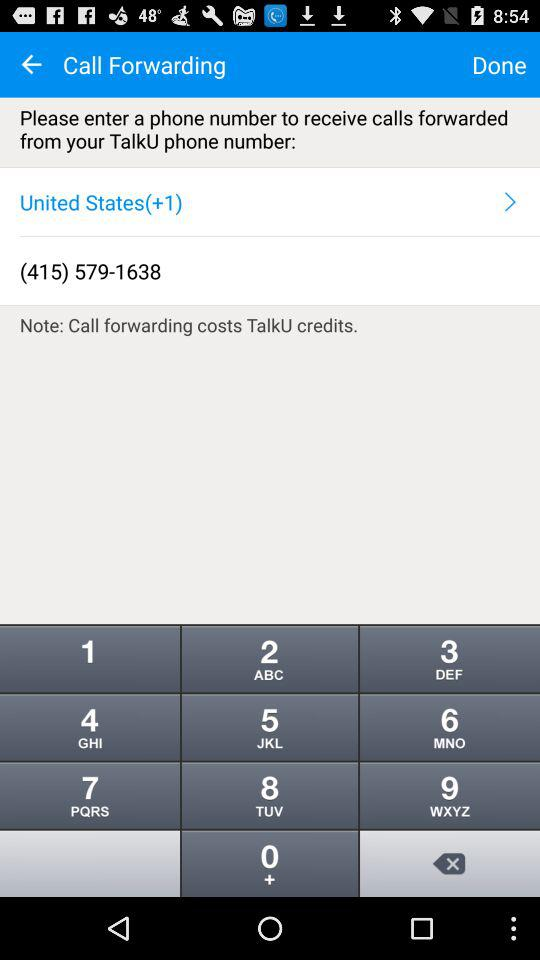What number is displayed? The number displayed is (415) 579-1638. 